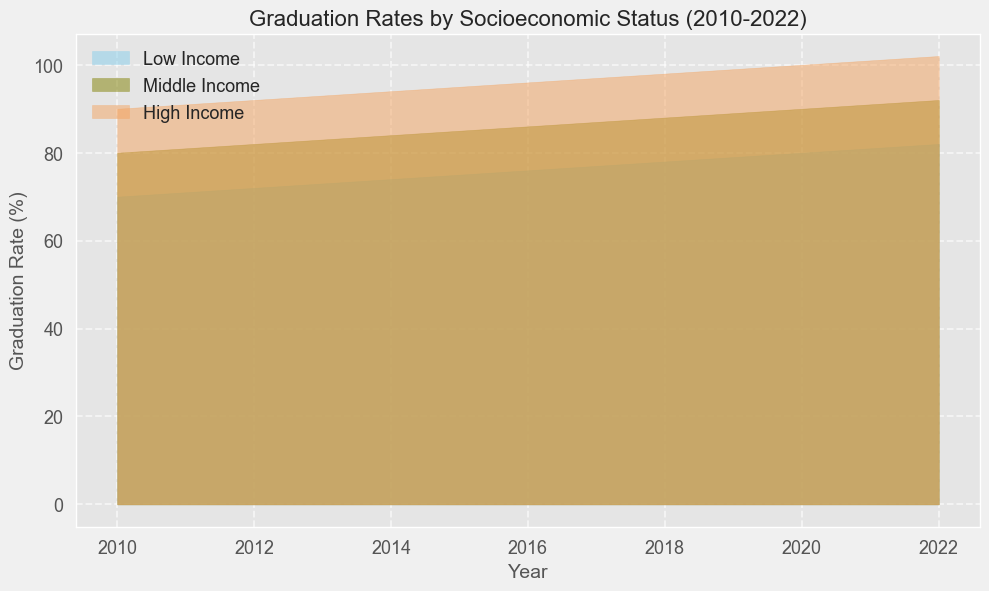Which year shows the highest graduation rate for low-income students? The figure indicates that graduation rates increase over time for low-income students. The highest rate is at the last year on the x-axis, which is 2022, indicated by the highest peak for the low-income section of the area plot.
Answer: 2022 Comparing 2010 and 2015, in which year did middle-income students have a higher graduation rate? The area height for middle-income students in 2015 is higher compared to 2010. Specifically, the figure shows middle-income rates progressing from 80% in 2010 to 85% in 2015.
Answer: 2015 By how much did the graduation rate for high-income students increase from 2010 to 2022? Graduation rates for high-income students rose from 90% in 2010 to 102% in 2022, as indicated by the endpoints of the high-income section of the area plot. The difference is 102% - 90% = 12%.
Answer: 12% What was the graduation rate difference between low-income and high-income students in 2020? The figure shows the graduation rate for low-income students at 80% and for high-income students at 100% in 2020. The difference is 100% - 80% = 20%.
Answer: 20% Which group shows the fastest rate of improvement in graduation rates from 2010 to 2022? Visually, the gap between each subsequent year is widest for low-income students, indicating the highest rate of change. Mathematically, low-income rates increased from 70% in 2010 to 82% in 2022, which is a change of 12%.
Answer: Low-income What is the average graduation rate for middle-income students across all years shown? First, add all the graduation rates for middle-income students from 2010 to 2022, which gives us the total: 80 + 81 + 82 + 83 + 84 + 85 + 86 + 87 + 88 + 89 + 90 + 91 + 92 = 1018. Then, divide by the number of years (13): 1018 / 13 ≈ 78.31.
Answer: 78.31 In which year do low-income students reach a graduation rate of at least 75%? The figure shows that low-income students reach 75% graduation rate in 2015 and onwards (2015 starts at 75%).
Answer: 2015 At which point does the gap between middle and low-income graduation rates become 3%? Look at the point where the middle-income rate (represented by the middle layer) exceeds the low-income rate by exactly 3%. This happens in 2011 where the rates are: middle-income 81%, low-income 71% (81 - 71 = 3%).
Answer: 2011 